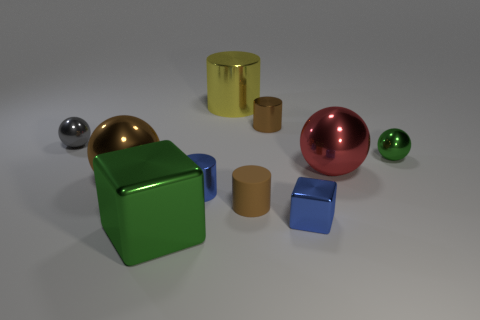Are the big brown object and the yellow thing made of the same material?
Your response must be concise. Yes. What number of other objects are the same material as the large green cube?
Make the answer very short. 8. Is the number of red shiny spheres greater than the number of large gray shiny cylinders?
Keep it short and to the point. Yes. Does the green thing that is behind the large brown shiny thing have the same shape as the yellow shiny object?
Offer a terse response. No. Is the number of brown shiny cylinders less than the number of small yellow matte balls?
Make the answer very short. No. What material is the green object that is the same size as the gray thing?
Provide a succinct answer. Metal. There is a big metallic cube; is it the same color as the metal block to the right of the matte object?
Provide a short and direct response. No. Is the number of small metal cylinders to the left of the tiny gray ball less than the number of large metallic cylinders?
Provide a succinct answer. Yes. How many gray rubber cubes are there?
Your answer should be very brief. 0. There is a big thing that is in front of the metallic cylinder in front of the brown sphere; what is its shape?
Your response must be concise. Cube. 